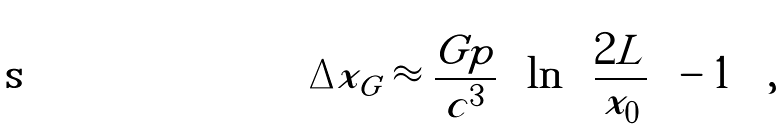Convert formula to latex. <formula><loc_0><loc_0><loc_500><loc_500>\Delta x _ { G } \approx \frac { G p } { c ^ { 3 } } \left [ \ln \left ( \frac { 2 L } { x _ { 0 } } \right ) - 1 \right ] \, ,</formula> 